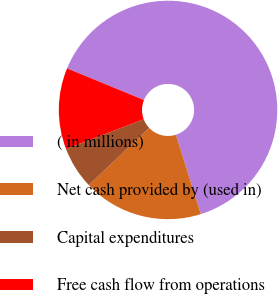<chart> <loc_0><loc_0><loc_500><loc_500><pie_chart><fcel>( in millions)<fcel>Net cash provided by (used in)<fcel>Capital expenditures<fcel>Free cash flow from operations<nl><fcel>63.92%<fcel>17.79%<fcel>6.26%<fcel>12.03%<nl></chart> 